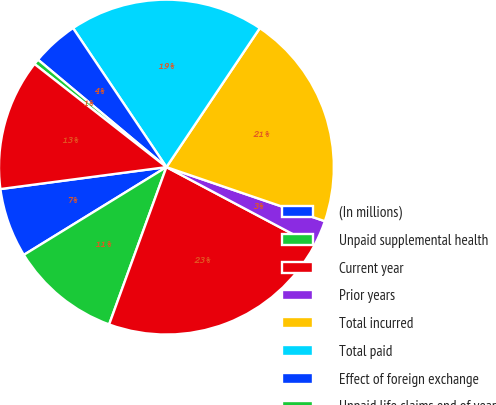Convert chart to OTSL. <chart><loc_0><loc_0><loc_500><loc_500><pie_chart><fcel>(In millions)<fcel>Unpaid supplemental health<fcel>Current year<fcel>Prior years<fcel>Total incurred<fcel>Total paid<fcel>Effect of foreign exchange<fcel>Unpaid life claims end of year<fcel>Total liability for unpaid<nl><fcel>6.69%<fcel>10.66%<fcel>22.8%<fcel>2.52%<fcel>20.82%<fcel>18.83%<fcel>4.5%<fcel>0.53%<fcel>12.65%<nl></chart> 